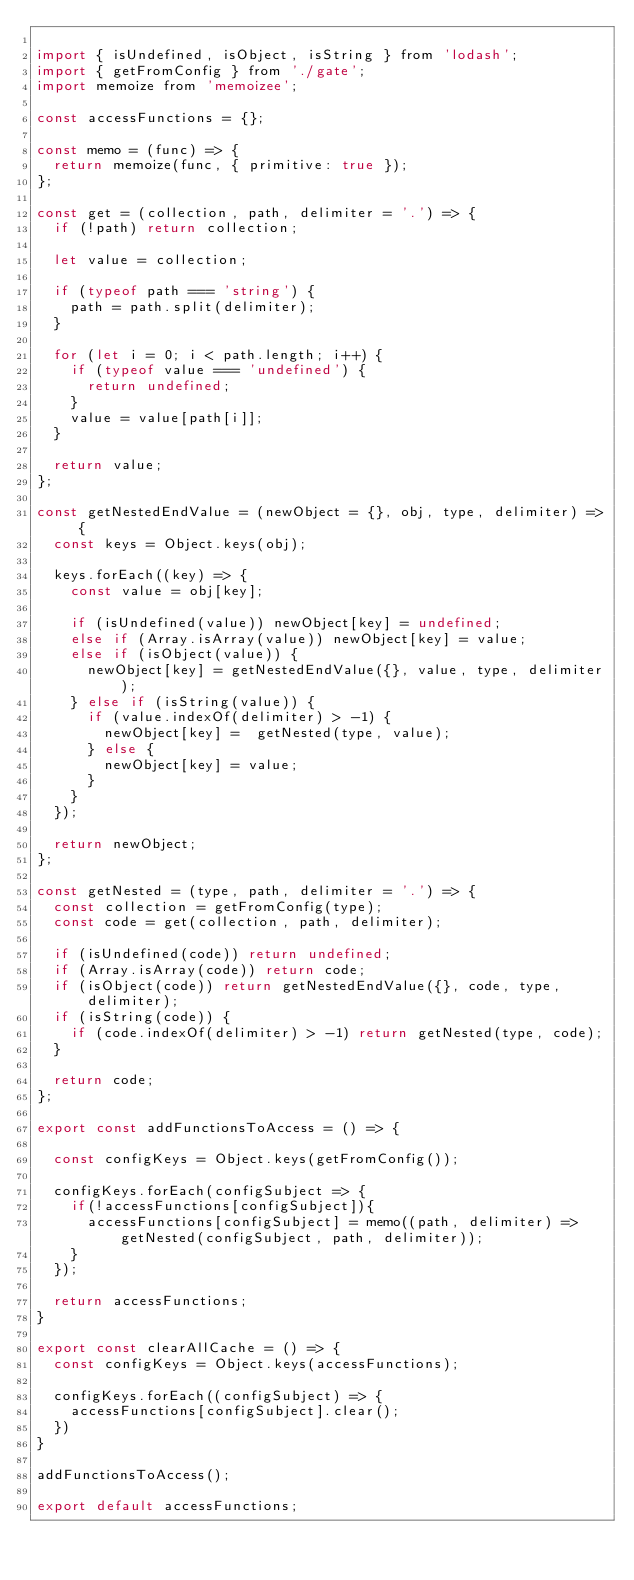<code> <loc_0><loc_0><loc_500><loc_500><_JavaScript_>
import { isUndefined, isObject, isString } from 'lodash';
import { getFromConfig } from './gate';
import memoize from 'memoizee';

const accessFunctions = {};

const memo = (func) => {
  return memoize(func, { primitive: true });
};

const get = (collection, path, delimiter = '.') => {
  if (!path) return collection;
  
  let value = collection;

  if (typeof path === 'string') {
    path = path.split(delimiter);
  }

  for (let i = 0; i < path.length; i++) {
    if (typeof value === 'undefined') {
      return undefined;
    }
    value = value[path[i]];
  }

  return value;
};

const getNestedEndValue = (newObject = {}, obj, type, delimiter) => {
  const keys = Object.keys(obj);

  keys.forEach((key) => {
    const value = obj[key];

    if (isUndefined(value)) newObject[key] = undefined;
    else if (Array.isArray(value)) newObject[key] = value;
    else if (isObject(value)) {
      newObject[key] = getNestedEndValue({}, value, type, delimiter);
    } else if (isString(value)) {
      if (value.indexOf(delimiter) > -1) {
        newObject[key] =  getNested(type, value);
      } else {
        newObject[key] = value;
      }
    }
  });

  return newObject;
};

const getNested = (type, path, delimiter = '.') => {
  const collection = getFromConfig(type);
  const code = get(collection, path, delimiter);

  if (isUndefined(code)) return undefined;
  if (Array.isArray(code)) return code;
  if (isObject(code)) return getNestedEndValue({}, code, type, delimiter);
  if (isString(code)) {
    if (code.indexOf(delimiter) > -1) return getNested(type, code);
  }

  return code;
};

export const addFunctionsToAccess = () => {

  const configKeys = Object.keys(getFromConfig());
  
  configKeys.forEach(configSubject => {
    if(!accessFunctions[configSubject]){
      accessFunctions[configSubject] = memo((path, delimiter) => getNested(configSubject, path, delimiter));
    }
  });

  return accessFunctions;
}

export const clearAllCache = () => {
  const configKeys = Object.keys(accessFunctions);

  configKeys.forEach((configSubject) => {
    accessFunctions[configSubject].clear();
  })
}

addFunctionsToAccess();

export default accessFunctions;
</code> 